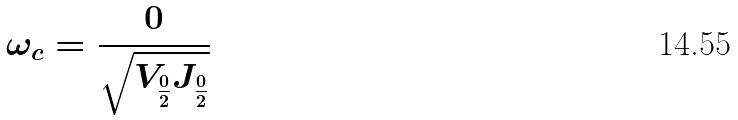Convert formula to latex. <formula><loc_0><loc_0><loc_500><loc_500>\omega _ { c } = \frac { 0 } { \sqrt { V _ { \frac { 0 } { 2 } } J _ { \frac { 0 } { 2 } } } }</formula> 